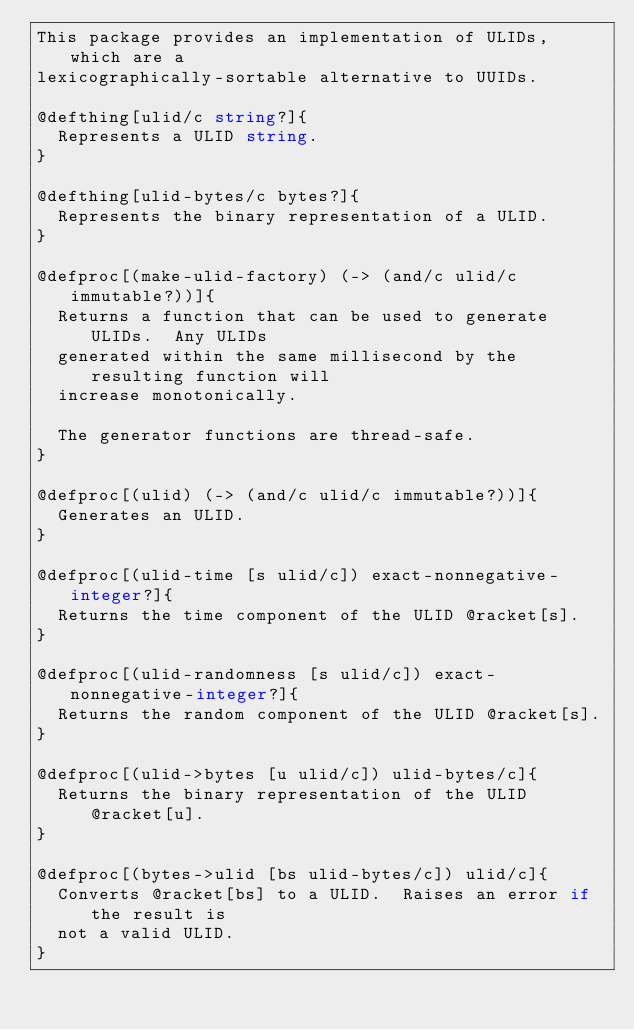Convert code to text. <code><loc_0><loc_0><loc_500><loc_500><_Racket_>This package provides an implementation of ULIDs, which are a
lexicographically-sortable alternative to UUIDs.

@defthing[ulid/c string?]{
  Represents a ULID string.
}

@defthing[ulid-bytes/c bytes?]{
  Represents the binary representation of a ULID.
}

@defproc[(make-ulid-factory) (-> (and/c ulid/c immutable?))]{
  Returns a function that can be used to generate ULIDs.  Any ULIDs
  generated within the same millisecond by the resulting function will
  increase monotonically.

  The generator functions are thread-safe.
}

@defproc[(ulid) (-> (and/c ulid/c immutable?))]{
  Generates an ULID.
}

@defproc[(ulid-time [s ulid/c]) exact-nonnegative-integer?]{
  Returns the time component of the ULID @racket[s].
}

@defproc[(ulid-randomness [s ulid/c]) exact-nonnegative-integer?]{
  Returns the random component of the ULID @racket[s].
}

@defproc[(ulid->bytes [u ulid/c]) ulid-bytes/c]{
  Returns the binary representation of the ULID @racket[u].
}

@defproc[(bytes->ulid [bs ulid-bytes/c]) ulid/c]{
  Converts @racket[bs] to a ULID.  Raises an error if the result is
  not a valid ULID.
}
</code> 